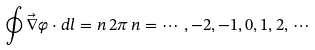Convert formula to latex. <formula><loc_0><loc_0><loc_500><loc_500>\oint \vec { \nabla } \varphi \cdot d l = n \, 2 \pi \, n = \cdots \, , - 2 , - 1 , 0 , 1 , 2 , \, \cdots</formula> 